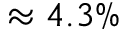Convert formula to latex. <formula><loc_0><loc_0><loc_500><loc_500>\approx 4 . 3 \%</formula> 